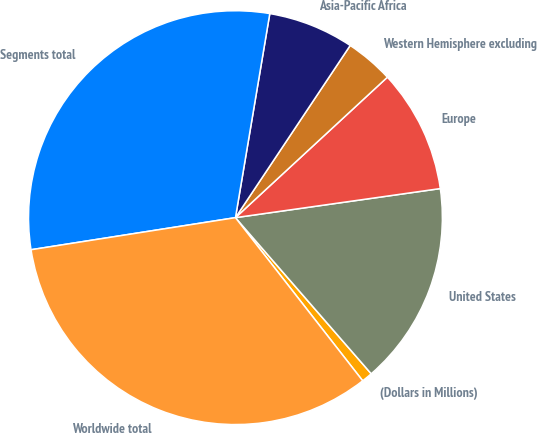<chart> <loc_0><loc_0><loc_500><loc_500><pie_chart><fcel>(Dollars in Millions)<fcel>United States<fcel>Europe<fcel>Western Hemisphere excluding<fcel>Asia-Pacific Africa<fcel>Segments total<fcel>Worldwide total<nl><fcel>0.85%<fcel>15.85%<fcel>9.63%<fcel>3.77%<fcel>6.7%<fcel>30.13%<fcel>33.06%<nl></chart> 